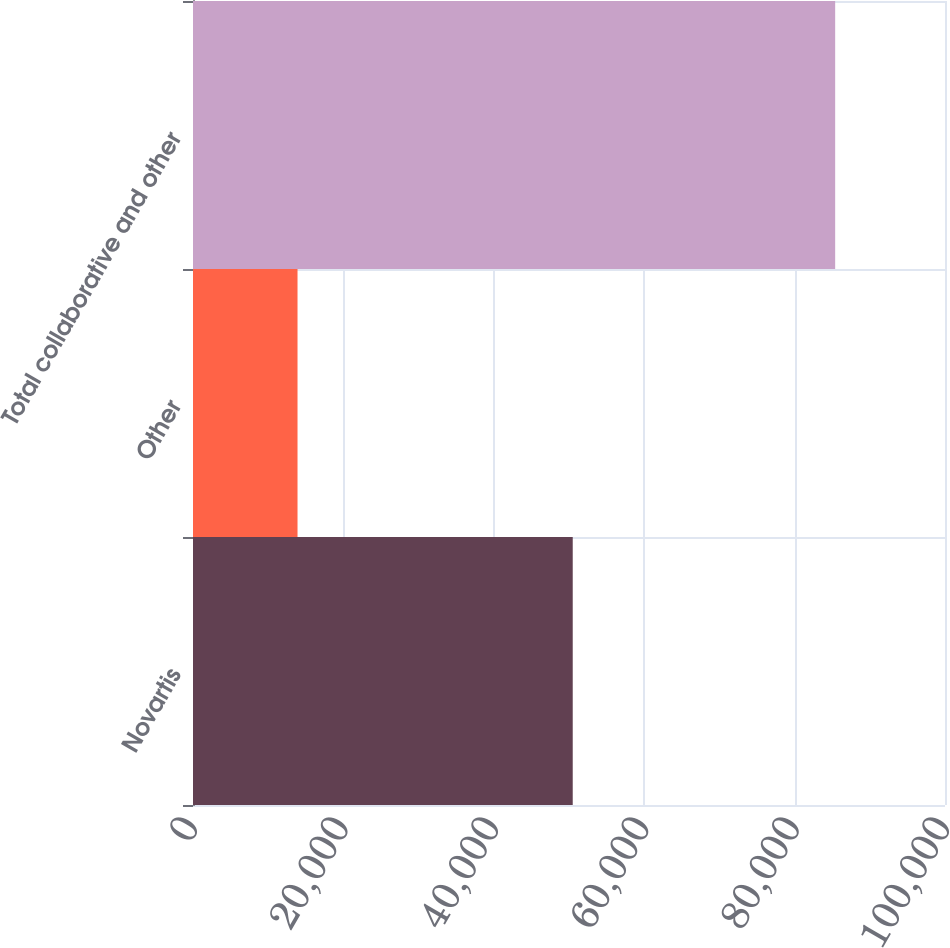Convert chart to OTSL. <chart><loc_0><loc_0><loc_500><loc_500><bar_chart><fcel>Novartis<fcel>Other<fcel>Total collaborative and other<nl><fcel>50497<fcel>13899<fcel>85395<nl></chart> 